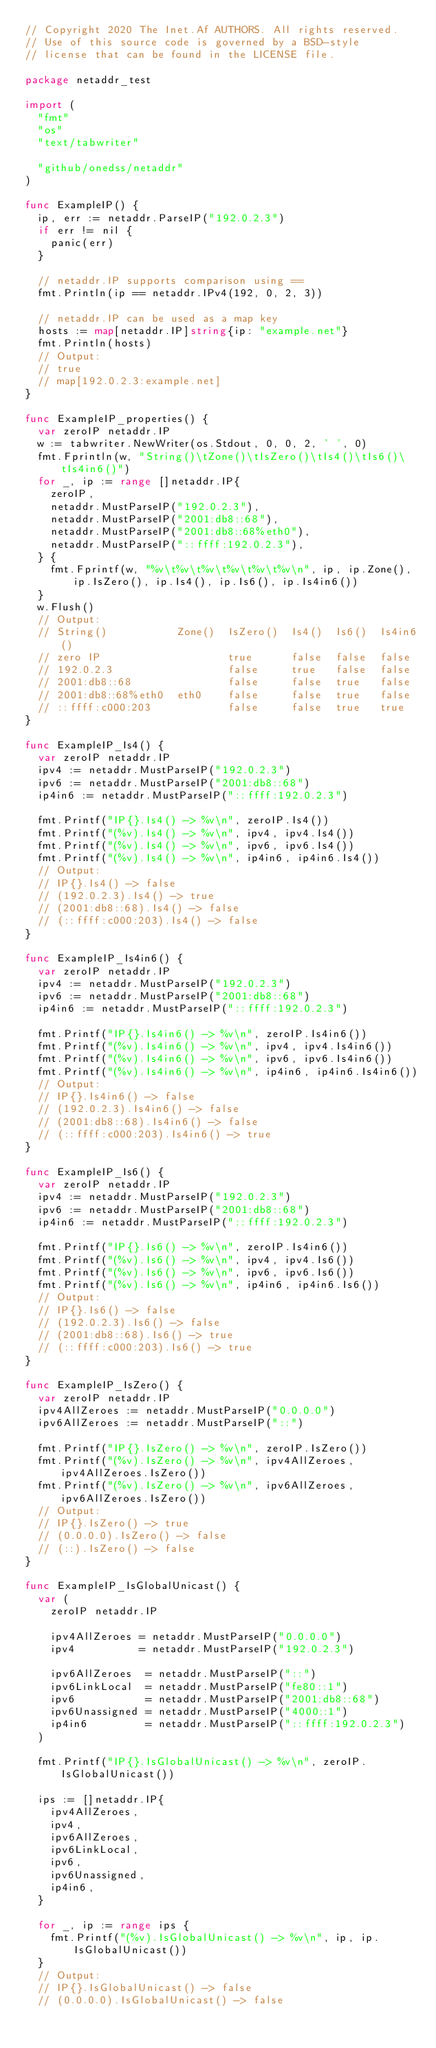Convert code to text. <code><loc_0><loc_0><loc_500><loc_500><_Go_>// Copyright 2020 The Inet.Af AUTHORS. All rights reserved.
// Use of this source code is governed by a BSD-style
// license that can be found in the LICENSE file.

package netaddr_test

import (
	"fmt"
	"os"
	"text/tabwriter"

	"github/onedss/netaddr"
)

func ExampleIP() {
	ip, err := netaddr.ParseIP("192.0.2.3")
	if err != nil {
		panic(err)
	}

	// netaddr.IP supports comparison using ==
	fmt.Println(ip == netaddr.IPv4(192, 0, 2, 3))

	// netaddr.IP can be used as a map key
	hosts := map[netaddr.IP]string{ip: "example.net"}
	fmt.Println(hosts)
	// Output:
	// true
	// map[192.0.2.3:example.net]
}

func ExampleIP_properties() {
	var zeroIP netaddr.IP
	w := tabwriter.NewWriter(os.Stdout, 0, 0, 2, ' ', 0)
	fmt.Fprintln(w, "String()\tZone()\tIsZero()\tIs4()\tIs6()\tIs4in6()")
	for _, ip := range []netaddr.IP{
		zeroIP,
		netaddr.MustParseIP("192.0.2.3"),
		netaddr.MustParseIP("2001:db8::68"),
		netaddr.MustParseIP("2001:db8::68%eth0"),
		netaddr.MustParseIP("::ffff:192.0.2.3"),
	} {
		fmt.Fprintf(w, "%v\t%v\t%v\t%v\t%v\t%v\n", ip, ip.Zone(), ip.IsZero(), ip.Is4(), ip.Is6(), ip.Is4in6())
	}
	w.Flush()
	// Output:
	// String()           Zone()  IsZero()  Is4()  Is6()  Is4in6()
	// zero IP                    true      false  false  false
	// 192.0.2.3                  false     true   false  false
	// 2001:db8::68               false     false  true   false
	// 2001:db8::68%eth0  eth0    false     false  true   false
	// ::ffff:c000:203            false     false  true   true
}

func ExampleIP_Is4() {
	var zeroIP netaddr.IP
	ipv4 := netaddr.MustParseIP("192.0.2.3")
	ipv6 := netaddr.MustParseIP("2001:db8::68")
	ip4in6 := netaddr.MustParseIP("::ffff:192.0.2.3")

	fmt.Printf("IP{}.Is4() -> %v\n", zeroIP.Is4())
	fmt.Printf("(%v).Is4() -> %v\n", ipv4, ipv4.Is4())
	fmt.Printf("(%v).Is4() -> %v\n", ipv6, ipv6.Is4())
	fmt.Printf("(%v).Is4() -> %v\n", ip4in6, ip4in6.Is4())
	// Output:
	// IP{}.Is4() -> false
	// (192.0.2.3).Is4() -> true
	// (2001:db8::68).Is4() -> false
	// (::ffff:c000:203).Is4() -> false
}

func ExampleIP_Is4in6() {
	var zeroIP netaddr.IP
	ipv4 := netaddr.MustParseIP("192.0.2.3")
	ipv6 := netaddr.MustParseIP("2001:db8::68")
	ip4in6 := netaddr.MustParseIP("::ffff:192.0.2.3")

	fmt.Printf("IP{}.Is4in6() -> %v\n", zeroIP.Is4in6())
	fmt.Printf("(%v).Is4in6() -> %v\n", ipv4, ipv4.Is4in6())
	fmt.Printf("(%v).Is4in6() -> %v\n", ipv6, ipv6.Is4in6())
	fmt.Printf("(%v).Is4in6() -> %v\n", ip4in6, ip4in6.Is4in6())
	// Output:
	// IP{}.Is4in6() -> false
	// (192.0.2.3).Is4in6() -> false
	// (2001:db8::68).Is4in6() -> false
	// (::ffff:c000:203).Is4in6() -> true
}

func ExampleIP_Is6() {
	var zeroIP netaddr.IP
	ipv4 := netaddr.MustParseIP("192.0.2.3")
	ipv6 := netaddr.MustParseIP("2001:db8::68")
	ip4in6 := netaddr.MustParseIP("::ffff:192.0.2.3")

	fmt.Printf("IP{}.Is6() -> %v\n", zeroIP.Is4in6())
	fmt.Printf("(%v).Is6() -> %v\n", ipv4, ipv4.Is6())
	fmt.Printf("(%v).Is6() -> %v\n", ipv6, ipv6.Is6())
	fmt.Printf("(%v).Is6() -> %v\n", ip4in6, ip4in6.Is6())
	// Output:
	// IP{}.Is6() -> false
	// (192.0.2.3).Is6() -> false
	// (2001:db8::68).Is6() -> true
	// (::ffff:c000:203).Is6() -> true
}

func ExampleIP_IsZero() {
	var zeroIP netaddr.IP
	ipv4AllZeroes := netaddr.MustParseIP("0.0.0.0")
	ipv6AllZeroes := netaddr.MustParseIP("::")

	fmt.Printf("IP{}.IsZero() -> %v\n", zeroIP.IsZero())
	fmt.Printf("(%v).IsZero() -> %v\n", ipv4AllZeroes, ipv4AllZeroes.IsZero())
	fmt.Printf("(%v).IsZero() -> %v\n", ipv6AllZeroes, ipv6AllZeroes.IsZero())
	// Output:
	// IP{}.IsZero() -> true
	// (0.0.0.0).IsZero() -> false
	// (::).IsZero() -> false
}

func ExampleIP_IsGlobalUnicast() {
	var (
		zeroIP netaddr.IP

		ipv4AllZeroes = netaddr.MustParseIP("0.0.0.0")
		ipv4          = netaddr.MustParseIP("192.0.2.3")

		ipv6AllZeroes  = netaddr.MustParseIP("::")
		ipv6LinkLocal  = netaddr.MustParseIP("fe80::1")
		ipv6           = netaddr.MustParseIP("2001:db8::68")
		ipv6Unassigned = netaddr.MustParseIP("4000::1")
		ip4in6         = netaddr.MustParseIP("::ffff:192.0.2.3")
	)

	fmt.Printf("IP{}.IsGlobalUnicast() -> %v\n", zeroIP.IsGlobalUnicast())

	ips := []netaddr.IP{
		ipv4AllZeroes,
		ipv4,
		ipv6AllZeroes,
		ipv6LinkLocal,
		ipv6,
		ipv6Unassigned,
		ip4in6,
	}

	for _, ip := range ips {
		fmt.Printf("(%v).IsGlobalUnicast() -> %v\n", ip, ip.IsGlobalUnicast())
	}
	// Output:
	// IP{}.IsGlobalUnicast() -> false
	// (0.0.0.0).IsGlobalUnicast() -> false</code> 